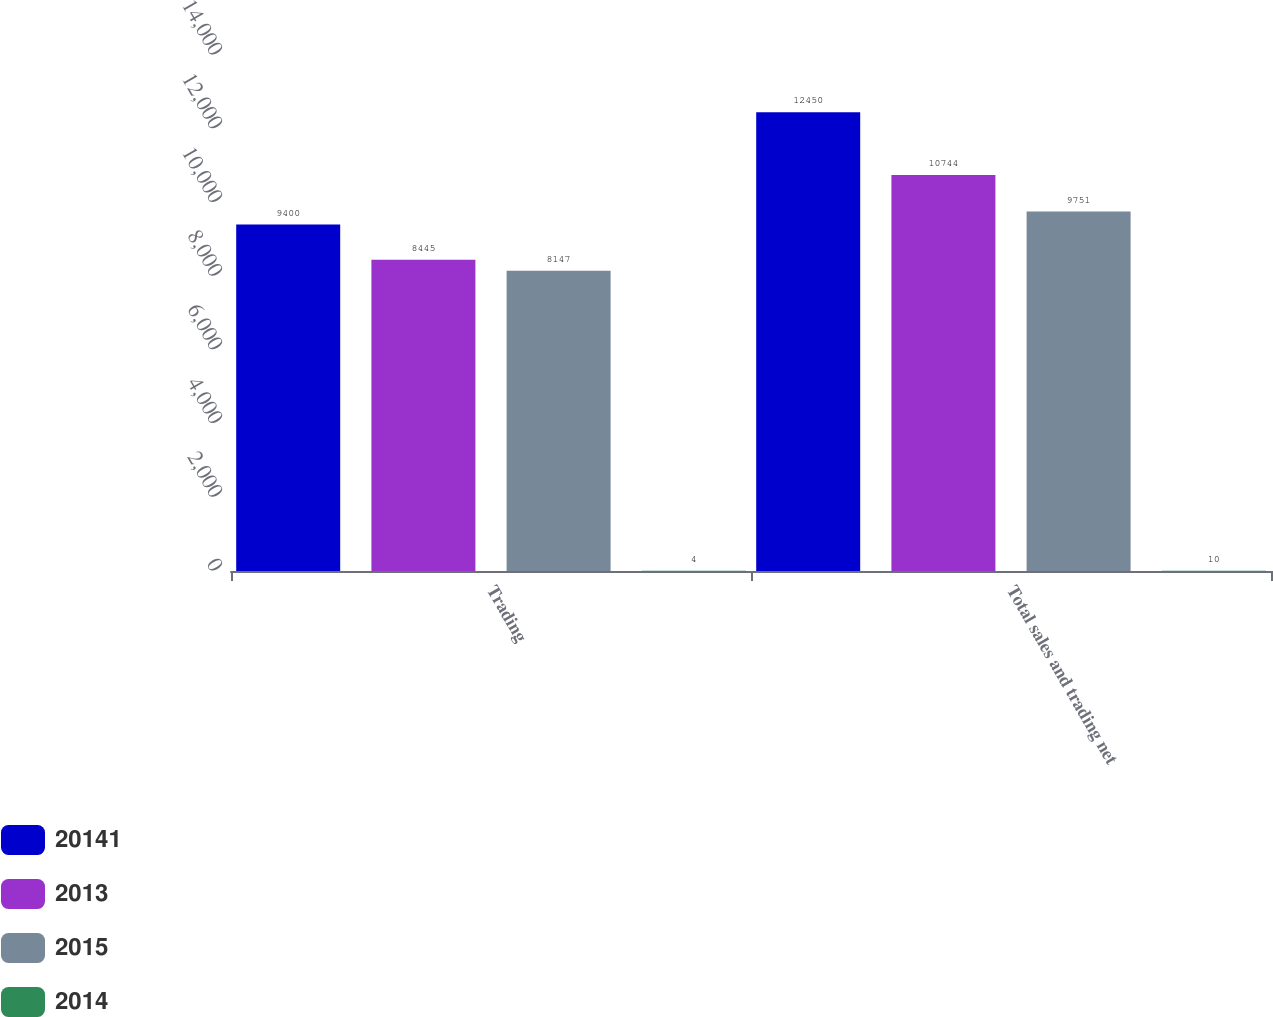Convert chart. <chart><loc_0><loc_0><loc_500><loc_500><stacked_bar_chart><ecel><fcel>Trading<fcel>Total sales and trading net<nl><fcel>20141<fcel>9400<fcel>12450<nl><fcel>2013<fcel>8445<fcel>10744<nl><fcel>2015<fcel>8147<fcel>9751<nl><fcel>2014<fcel>4<fcel>10<nl></chart> 